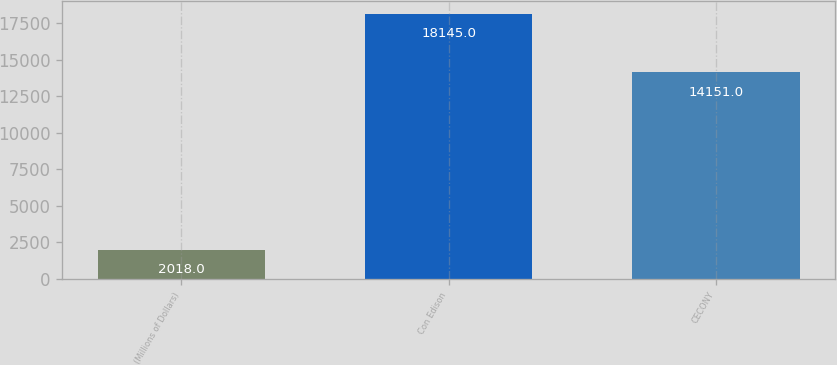Convert chart to OTSL. <chart><loc_0><loc_0><loc_500><loc_500><bar_chart><fcel>(Millions of Dollars)<fcel>Con Edison<fcel>CECONY<nl><fcel>2018<fcel>18145<fcel>14151<nl></chart> 